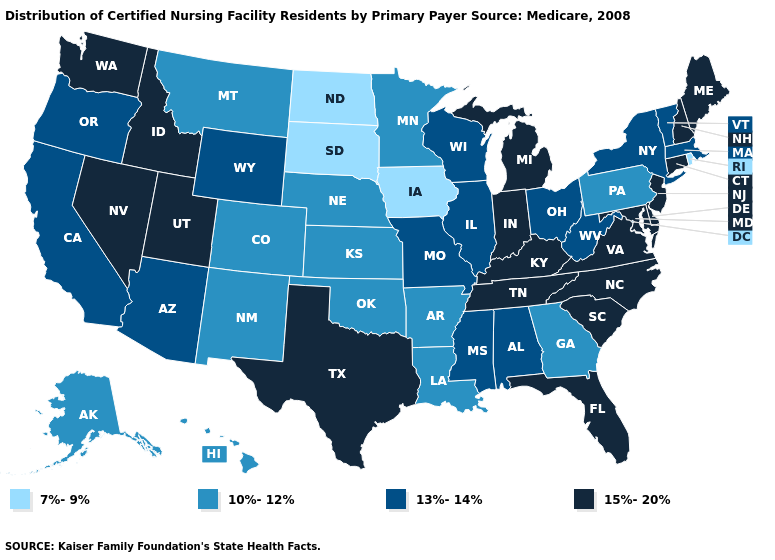Among the states that border South Carolina , which have the highest value?
Give a very brief answer. North Carolina. Name the states that have a value in the range 7%-9%?
Be succinct. Iowa, North Dakota, Rhode Island, South Dakota. What is the highest value in the Northeast ?
Keep it brief. 15%-20%. Name the states that have a value in the range 13%-14%?
Give a very brief answer. Alabama, Arizona, California, Illinois, Massachusetts, Mississippi, Missouri, New York, Ohio, Oregon, Vermont, West Virginia, Wisconsin, Wyoming. What is the highest value in the Northeast ?
Short answer required. 15%-20%. Which states have the highest value in the USA?
Write a very short answer. Connecticut, Delaware, Florida, Idaho, Indiana, Kentucky, Maine, Maryland, Michigan, Nevada, New Hampshire, New Jersey, North Carolina, South Carolina, Tennessee, Texas, Utah, Virginia, Washington. Name the states that have a value in the range 13%-14%?
Concise answer only. Alabama, Arizona, California, Illinois, Massachusetts, Mississippi, Missouri, New York, Ohio, Oregon, Vermont, West Virginia, Wisconsin, Wyoming. Does the first symbol in the legend represent the smallest category?
Write a very short answer. Yes. What is the highest value in states that border North Dakota?
Be succinct. 10%-12%. What is the lowest value in the MidWest?
Be succinct. 7%-9%. What is the value of Florida?
Give a very brief answer. 15%-20%. Does Pennsylvania have a higher value than South Dakota?
Write a very short answer. Yes. Does the map have missing data?
Keep it brief. No. What is the value of Iowa?
Keep it brief. 7%-9%. What is the value of Hawaii?
Give a very brief answer. 10%-12%. 